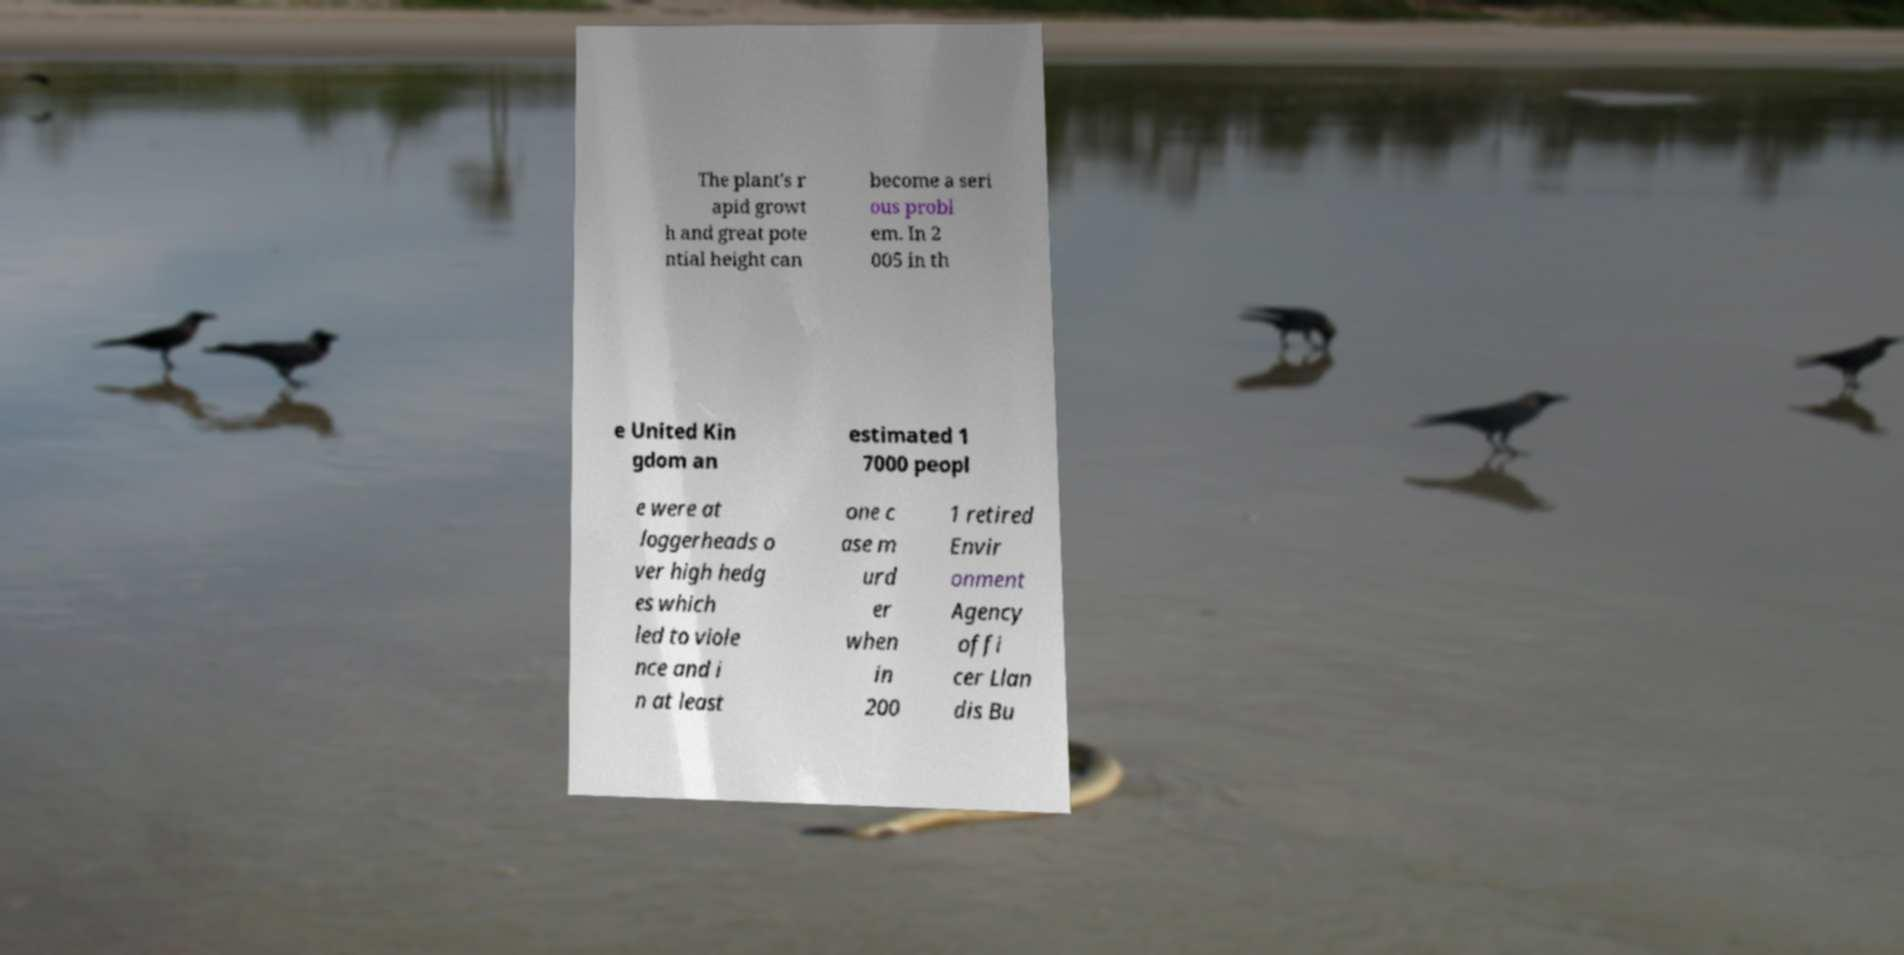Could you assist in decoding the text presented in this image and type it out clearly? The plant's r apid growt h and great pote ntial height can become a seri ous probl em. In 2 005 in th e United Kin gdom an estimated 1 7000 peopl e were at loggerheads o ver high hedg es which led to viole nce and i n at least one c ase m urd er when in 200 1 retired Envir onment Agency offi cer Llan dis Bu 